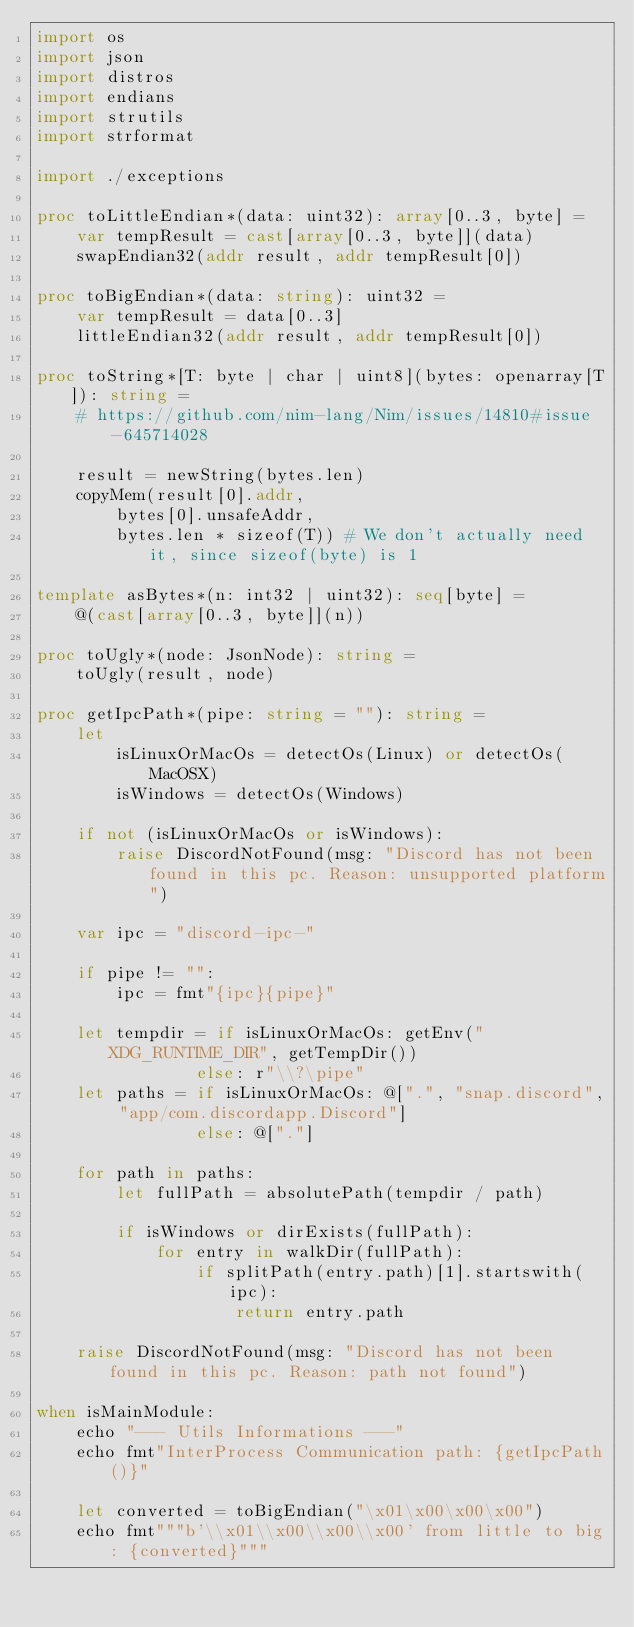<code> <loc_0><loc_0><loc_500><loc_500><_Nim_>import os
import json
import distros
import endians
import strutils
import strformat

import ./exceptions

proc toLittleEndian*(data: uint32): array[0..3, byte] =
    var tempResult = cast[array[0..3, byte]](data)
    swapEndian32(addr result, addr tempResult[0])

proc toBigEndian*(data: string): uint32 =
    var tempResult = data[0..3]
    littleEndian32(addr result, addr tempResult[0])

proc toString*[T: byte | char | uint8](bytes: openarray[T]): string =
    # https://github.com/nim-lang/Nim/issues/14810#issue-645714028

    result = newString(bytes.len)
    copyMem(result[0].addr,
        bytes[0].unsafeAddr,
        bytes.len * sizeof(T)) # We don't actually need it, since sizeof(byte) is 1

template asBytes*(n: int32 | uint32): seq[byte] =
    @(cast[array[0..3, byte]](n))

proc toUgly*(node: JsonNode): string =
    toUgly(result, node)

proc getIpcPath*(pipe: string = ""): string =
    let
        isLinuxOrMacOs = detectOs(Linux) or detectOs(MacOSX)
        isWindows = detectOs(Windows)

    if not (isLinuxOrMacOs or isWindows):
        raise DiscordNotFound(msg: "Discord has not been found in this pc. Reason: unsupported platform")

    var ipc = "discord-ipc-"

    if pipe != "":
        ipc = fmt"{ipc}{pipe}"

    let tempdir = if isLinuxOrMacOs: getEnv("XDG_RUNTIME_DIR", getTempDir())
                else: r"\\?\pipe"
    let paths = if isLinuxOrMacOs: @[".", "snap.discord", "app/com.discordapp.Discord"]
                else: @["."]

    for path in paths:
        let fullPath = absolutePath(tempdir / path)

        if isWindows or dirExists(fullPath):
            for entry in walkDir(fullPath):
                if splitPath(entry.path)[1].startswith(ipc):
                    return entry.path

    raise DiscordNotFound(msg: "Discord has not been found in this pc. Reason: path not found")

when isMainModule:
    echo "--- Utils Informations ---"
    echo fmt"InterProcess Communication path: {getIpcPath()}"

    let converted = toBigEndian("\x01\x00\x00\x00")
    echo fmt"""b'\\x01\\x00\\x00\\x00' from little to big: {converted}"""
</code> 